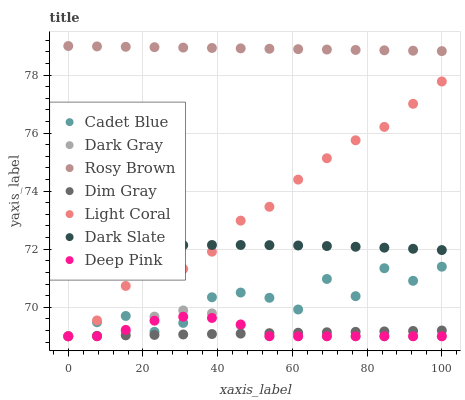Does Dim Gray have the minimum area under the curve?
Answer yes or no. Yes. Does Rosy Brown have the maximum area under the curve?
Answer yes or no. Yes. Does Cadet Blue have the minimum area under the curve?
Answer yes or no. No. Does Cadet Blue have the maximum area under the curve?
Answer yes or no. No. Is Dim Gray the smoothest?
Answer yes or no. Yes. Is Cadet Blue the roughest?
Answer yes or no. Yes. Is Rosy Brown the smoothest?
Answer yes or no. No. Is Rosy Brown the roughest?
Answer yes or no. No. Does Light Coral have the lowest value?
Answer yes or no. Yes. Does Rosy Brown have the lowest value?
Answer yes or no. No. Does Rosy Brown have the highest value?
Answer yes or no. Yes. Does Cadet Blue have the highest value?
Answer yes or no. No. Is Dark Gray less than Dark Slate?
Answer yes or no. Yes. Is Dark Slate greater than Dim Gray?
Answer yes or no. Yes. Does Dark Gray intersect Dim Gray?
Answer yes or no. Yes. Is Dark Gray less than Dim Gray?
Answer yes or no. No. Is Dark Gray greater than Dim Gray?
Answer yes or no. No. Does Dark Gray intersect Dark Slate?
Answer yes or no. No. 